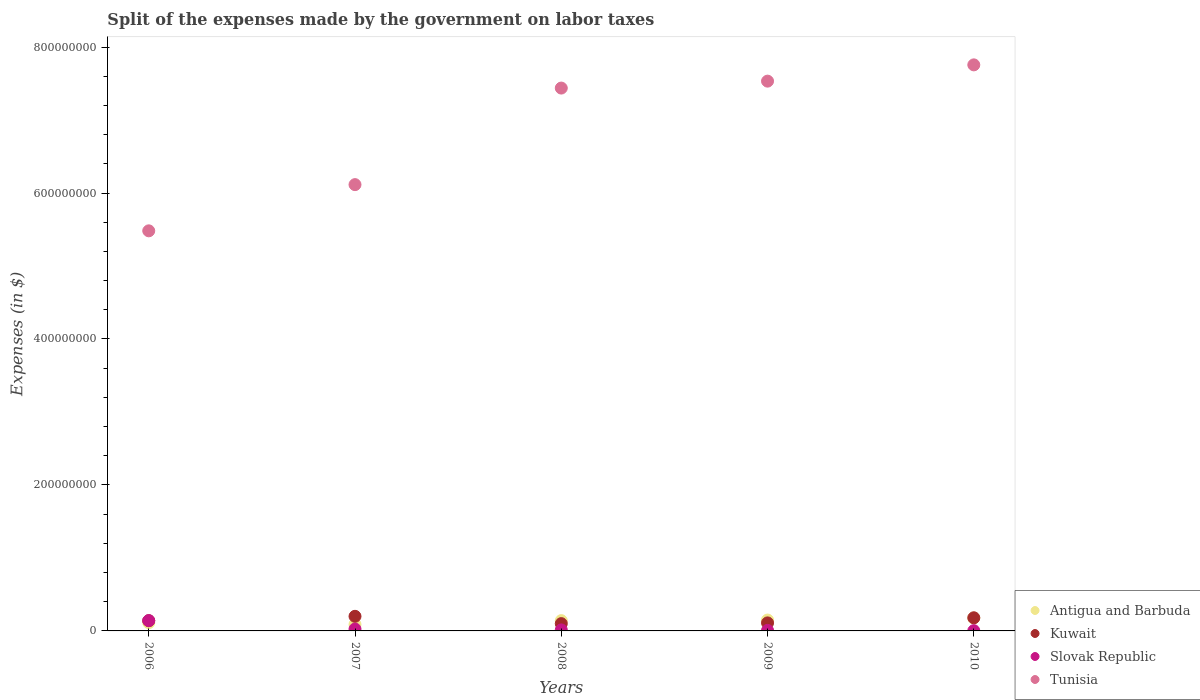What is the expenses made by the government on labor taxes in Tunisia in 2010?
Make the answer very short. 7.76e+08. Across all years, what is the maximum expenses made by the government on labor taxes in Tunisia?
Ensure brevity in your answer.  7.76e+08. Across all years, what is the minimum expenses made by the government on labor taxes in Antigua and Barbuda?
Offer a terse response. 8.90e+06. In which year was the expenses made by the government on labor taxes in Kuwait minimum?
Provide a short and direct response. 2008. What is the total expenses made by the government on labor taxes in Slovak Republic in the graph?
Your answer should be compact. 1.92e+07. What is the difference between the expenses made by the government on labor taxes in Antigua and Barbuda in 2008 and that in 2009?
Offer a terse response. -8.00e+05. What is the difference between the expenses made by the government on labor taxes in Tunisia in 2007 and the expenses made by the government on labor taxes in Antigua and Barbuda in 2009?
Offer a terse response. 5.97e+08. What is the average expenses made by the government on labor taxes in Antigua and Barbuda per year?
Keep it short and to the point. 1.34e+07. In the year 2009, what is the difference between the expenses made by the government on labor taxes in Slovak Republic and expenses made by the government on labor taxes in Tunisia?
Your response must be concise. -7.53e+08. What is the ratio of the expenses made by the government on labor taxes in Kuwait in 2007 to that in 2008?
Your answer should be very brief. 2. Is the difference between the expenses made by the government on labor taxes in Slovak Republic in 2007 and 2008 greater than the difference between the expenses made by the government on labor taxes in Tunisia in 2007 and 2008?
Make the answer very short. Yes. What is the difference between the highest and the second highest expenses made by the government on labor taxes in Tunisia?
Provide a short and direct response. 2.23e+07. What is the difference between the highest and the lowest expenses made by the government on labor taxes in Antigua and Barbuda?
Give a very brief answer. 8.80e+06. Is the sum of the expenses made by the government on labor taxes in Slovak Republic in 2009 and 2010 greater than the maximum expenses made by the government on labor taxes in Tunisia across all years?
Provide a succinct answer. No. Is it the case that in every year, the sum of the expenses made by the government on labor taxes in Tunisia and expenses made by the government on labor taxes in Antigua and Barbuda  is greater than the sum of expenses made by the government on labor taxes in Kuwait and expenses made by the government on labor taxes in Slovak Republic?
Your answer should be very brief. No. Does the expenses made by the government on labor taxes in Antigua and Barbuda monotonically increase over the years?
Make the answer very short. No. Is the expenses made by the government on labor taxes in Slovak Republic strictly greater than the expenses made by the government on labor taxes in Kuwait over the years?
Offer a terse response. No. Is the expenses made by the government on labor taxes in Antigua and Barbuda strictly less than the expenses made by the government on labor taxes in Tunisia over the years?
Your response must be concise. Yes. How many dotlines are there?
Your response must be concise. 4. What is the difference between two consecutive major ticks on the Y-axis?
Your answer should be very brief. 2.00e+08. Does the graph contain grids?
Offer a terse response. No. Where does the legend appear in the graph?
Keep it short and to the point. Bottom right. How many legend labels are there?
Give a very brief answer. 4. How are the legend labels stacked?
Your answer should be very brief. Vertical. What is the title of the graph?
Offer a very short reply. Split of the expenses made by the government on labor taxes. What is the label or title of the Y-axis?
Your answer should be very brief. Expenses (in $). What is the Expenses (in $) in Antigua and Barbuda in 2006?
Your answer should be very brief. 1.13e+07. What is the Expenses (in $) of Kuwait in 2006?
Ensure brevity in your answer.  1.40e+07. What is the Expenses (in $) in Slovak Republic in 2006?
Offer a terse response. 1.41e+07. What is the Expenses (in $) of Tunisia in 2006?
Keep it short and to the point. 5.48e+08. What is the Expenses (in $) of Antigua and Barbuda in 2007?
Your response must be concise. 8.90e+06. What is the Expenses (in $) in Slovak Republic in 2007?
Your answer should be compact. 2.58e+06. What is the Expenses (in $) of Tunisia in 2007?
Provide a short and direct response. 6.12e+08. What is the Expenses (in $) of Antigua and Barbuda in 2008?
Give a very brief answer. 1.41e+07. What is the Expenses (in $) in Slovak Republic in 2008?
Provide a short and direct response. 1.39e+06. What is the Expenses (in $) of Tunisia in 2008?
Offer a terse response. 7.44e+08. What is the Expenses (in $) of Antigua and Barbuda in 2009?
Provide a short and direct response. 1.49e+07. What is the Expenses (in $) of Kuwait in 2009?
Provide a succinct answer. 1.10e+07. What is the Expenses (in $) in Slovak Republic in 2009?
Give a very brief answer. 7.25e+05. What is the Expenses (in $) in Tunisia in 2009?
Give a very brief answer. 7.53e+08. What is the Expenses (in $) in Antigua and Barbuda in 2010?
Your response must be concise. 1.77e+07. What is the Expenses (in $) of Kuwait in 2010?
Provide a short and direct response. 1.80e+07. What is the Expenses (in $) of Slovak Republic in 2010?
Provide a succinct answer. 3.61e+05. What is the Expenses (in $) of Tunisia in 2010?
Make the answer very short. 7.76e+08. Across all years, what is the maximum Expenses (in $) of Antigua and Barbuda?
Provide a short and direct response. 1.77e+07. Across all years, what is the maximum Expenses (in $) in Kuwait?
Keep it short and to the point. 2.00e+07. Across all years, what is the maximum Expenses (in $) of Slovak Republic?
Your answer should be very brief. 1.41e+07. Across all years, what is the maximum Expenses (in $) of Tunisia?
Your response must be concise. 7.76e+08. Across all years, what is the minimum Expenses (in $) in Antigua and Barbuda?
Keep it short and to the point. 8.90e+06. Across all years, what is the minimum Expenses (in $) of Kuwait?
Keep it short and to the point. 1.00e+07. Across all years, what is the minimum Expenses (in $) of Slovak Republic?
Ensure brevity in your answer.  3.61e+05. Across all years, what is the minimum Expenses (in $) of Tunisia?
Provide a succinct answer. 5.48e+08. What is the total Expenses (in $) of Antigua and Barbuda in the graph?
Offer a very short reply. 6.69e+07. What is the total Expenses (in $) of Kuwait in the graph?
Make the answer very short. 7.30e+07. What is the total Expenses (in $) in Slovak Republic in the graph?
Ensure brevity in your answer.  1.92e+07. What is the total Expenses (in $) of Tunisia in the graph?
Make the answer very short. 3.43e+09. What is the difference between the Expenses (in $) of Antigua and Barbuda in 2006 and that in 2007?
Your answer should be very brief. 2.40e+06. What is the difference between the Expenses (in $) in Kuwait in 2006 and that in 2007?
Keep it short and to the point. -6.00e+06. What is the difference between the Expenses (in $) of Slovak Republic in 2006 and that in 2007?
Your answer should be compact. 1.15e+07. What is the difference between the Expenses (in $) of Tunisia in 2006 and that in 2007?
Keep it short and to the point. -6.33e+07. What is the difference between the Expenses (in $) of Antigua and Barbuda in 2006 and that in 2008?
Provide a short and direct response. -2.80e+06. What is the difference between the Expenses (in $) in Kuwait in 2006 and that in 2008?
Offer a very short reply. 4.00e+06. What is the difference between the Expenses (in $) in Slovak Republic in 2006 and that in 2008?
Ensure brevity in your answer.  1.27e+07. What is the difference between the Expenses (in $) in Tunisia in 2006 and that in 2008?
Offer a very short reply. -1.96e+08. What is the difference between the Expenses (in $) of Antigua and Barbuda in 2006 and that in 2009?
Your answer should be very brief. -3.60e+06. What is the difference between the Expenses (in $) in Slovak Republic in 2006 and that in 2009?
Keep it short and to the point. 1.34e+07. What is the difference between the Expenses (in $) in Tunisia in 2006 and that in 2009?
Keep it short and to the point. -2.05e+08. What is the difference between the Expenses (in $) in Antigua and Barbuda in 2006 and that in 2010?
Make the answer very short. -6.40e+06. What is the difference between the Expenses (in $) in Kuwait in 2006 and that in 2010?
Your response must be concise. -4.00e+06. What is the difference between the Expenses (in $) of Slovak Republic in 2006 and that in 2010?
Provide a short and direct response. 1.37e+07. What is the difference between the Expenses (in $) of Tunisia in 2006 and that in 2010?
Your answer should be very brief. -2.27e+08. What is the difference between the Expenses (in $) of Antigua and Barbuda in 2007 and that in 2008?
Give a very brief answer. -5.20e+06. What is the difference between the Expenses (in $) of Kuwait in 2007 and that in 2008?
Your answer should be compact. 1.00e+07. What is the difference between the Expenses (in $) in Slovak Republic in 2007 and that in 2008?
Your answer should be compact. 1.19e+06. What is the difference between the Expenses (in $) of Tunisia in 2007 and that in 2008?
Make the answer very short. -1.32e+08. What is the difference between the Expenses (in $) of Antigua and Barbuda in 2007 and that in 2009?
Ensure brevity in your answer.  -6.00e+06. What is the difference between the Expenses (in $) of Kuwait in 2007 and that in 2009?
Ensure brevity in your answer.  9.00e+06. What is the difference between the Expenses (in $) of Slovak Republic in 2007 and that in 2009?
Your answer should be compact. 1.86e+06. What is the difference between the Expenses (in $) in Tunisia in 2007 and that in 2009?
Your response must be concise. -1.42e+08. What is the difference between the Expenses (in $) of Antigua and Barbuda in 2007 and that in 2010?
Offer a very short reply. -8.80e+06. What is the difference between the Expenses (in $) in Slovak Republic in 2007 and that in 2010?
Keep it short and to the point. 2.22e+06. What is the difference between the Expenses (in $) of Tunisia in 2007 and that in 2010?
Ensure brevity in your answer.  -1.64e+08. What is the difference between the Expenses (in $) of Antigua and Barbuda in 2008 and that in 2009?
Keep it short and to the point. -8.00e+05. What is the difference between the Expenses (in $) of Kuwait in 2008 and that in 2009?
Your response must be concise. -1.00e+06. What is the difference between the Expenses (in $) in Slovak Republic in 2008 and that in 2009?
Make the answer very short. 6.67e+05. What is the difference between the Expenses (in $) of Tunisia in 2008 and that in 2009?
Provide a succinct answer. -9.50e+06. What is the difference between the Expenses (in $) of Antigua and Barbuda in 2008 and that in 2010?
Provide a succinct answer. -3.60e+06. What is the difference between the Expenses (in $) in Kuwait in 2008 and that in 2010?
Ensure brevity in your answer.  -8.00e+06. What is the difference between the Expenses (in $) of Slovak Republic in 2008 and that in 2010?
Your answer should be compact. 1.03e+06. What is the difference between the Expenses (in $) of Tunisia in 2008 and that in 2010?
Keep it short and to the point. -3.18e+07. What is the difference between the Expenses (in $) of Antigua and Barbuda in 2009 and that in 2010?
Your answer should be very brief. -2.80e+06. What is the difference between the Expenses (in $) of Kuwait in 2009 and that in 2010?
Ensure brevity in your answer.  -7.00e+06. What is the difference between the Expenses (in $) of Slovak Republic in 2009 and that in 2010?
Give a very brief answer. 3.64e+05. What is the difference between the Expenses (in $) of Tunisia in 2009 and that in 2010?
Make the answer very short. -2.23e+07. What is the difference between the Expenses (in $) in Antigua and Barbuda in 2006 and the Expenses (in $) in Kuwait in 2007?
Make the answer very short. -8.70e+06. What is the difference between the Expenses (in $) of Antigua and Barbuda in 2006 and the Expenses (in $) of Slovak Republic in 2007?
Offer a very short reply. 8.72e+06. What is the difference between the Expenses (in $) in Antigua and Barbuda in 2006 and the Expenses (in $) in Tunisia in 2007?
Provide a short and direct response. -6.00e+08. What is the difference between the Expenses (in $) of Kuwait in 2006 and the Expenses (in $) of Slovak Republic in 2007?
Give a very brief answer. 1.14e+07. What is the difference between the Expenses (in $) of Kuwait in 2006 and the Expenses (in $) of Tunisia in 2007?
Your response must be concise. -5.98e+08. What is the difference between the Expenses (in $) of Slovak Republic in 2006 and the Expenses (in $) of Tunisia in 2007?
Offer a very short reply. -5.97e+08. What is the difference between the Expenses (in $) of Antigua and Barbuda in 2006 and the Expenses (in $) of Kuwait in 2008?
Give a very brief answer. 1.30e+06. What is the difference between the Expenses (in $) in Antigua and Barbuda in 2006 and the Expenses (in $) in Slovak Republic in 2008?
Provide a short and direct response. 9.91e+06. What is the difference between the Expenses (in $) of Antigua and Barbuda in 2006 and the Expenses (in $) of Tunisia in 2008?
Make the answer very short. -7.32e+08. What is the difference between the Expenses (in $) in Kuwait in 2006 and the Expenses (in $) in Slovak Republic in 2008?
Your answer should be compact. 1.26e+07. What is the difference between the Expenses (in $) of Kuwait in 2006 and the Expenses (in $) of Tunisia in 2008?
Offer a very short reply. -7.30e+08. What is the difference between the Expenses (in $) in Slovak Republic in 2006 and the Expenses (in $) in Tunisia in 2008?
Your response must be concise. -7.30e+08. What is the difference between the Expenses (in $) of Antigua and Barbuda in 2006 and the Expenses (in $) of Slovak Republic in 2009?
Your answer should be compact. 1.06e+07. What is the difference between the Expenses (in $) in Antigua and Barbuda in 2006 and the Expenses (in $) in Tunisia in 2009?
Keep it short and to the point. -7.42e+08. What is the difference between the Expenses (in $) in Kuwait in 2006 and the Expenses (in $) in Slovak Republic in 2009?
Give a very brief answer. 1.33e+07. What is the difference between the Expenses (in $) of Kuwait in 2006 and the Expenses (in $) of Tunisia in 2009?
Provide a short and direct response. -7.39e+08. What is the difference between the Expenses (in $) in Slovak Republic in 2006 and the Expenses (in $) in Tunisia in 2009?
Make the answer very short. -7.39e+08. What is the difference between the Expenses (in $) of Antigua and Barbuda in 2006 and the Expenses (in $) of Kuwait in 2010?
Offer a terse response. -6.70e+06. What is the difference between the Expenses (in $) of Antigua and Barbuda in 2006 and the Expenses (in $) of Slovak Republic in 2010?
Keep it short and to the point. 1.09e+07. What is the difference between the Expenses (in $) of Antigua and Barbuda in 2006 and the Expenses (in $) of Tunisia in 2010?
Offer a very short reply. -7.64e+08. What is the difference between the Expenses (in $) in Kuwait in 2006 and the Expenses (in $) in Slovak Republic in 2010?
Offer a terse response. 1.36e+07. What is the difference between the Expenses (in $) of Kuwait in 2006 and the Expenses (in $) of Tunisia in 2010?
Offer a very short reply. -7.62e+08. What is the difference between the Expenses (in $) of Slovak Republic in 2006 and the Expenses (in $) of Tunisia in 2010?
Your answer should be compact. -7.61e+08. What is the difference between the Expenses (in $) in Antigua and Barbuda in 2007 and the Expenses (in $) in Kuwait in 2008?
Ensure brevity in your answer.  -1.10e+06. What is the difference between the Expenses (in $) in Antigua and Barbuda in 2007 and the Expenses (in $) in Slovak Republic in 2008?
Give a very brief answer. 7.51e+06. What is the difference between the Expenses (in $) of Antigua and Barbuda in 2007 and the Expenses (in $) of Tunisia in 2008?
Your answer should be compact. -7.35e+08. What is the difference between the Expenses (in $) in Kuwait in 2007 and the Expenses (in $) in Slovak Republic in 2008?
Provide a succinct answer. 1.86e+07. What is the difference between the Expenses (in $) in Kuwait in 2007 and the Expenses (in $) in Tunisia in 2008?
Offer a very short reply. -7.24e+08. What is the difference between the Expenses (in $) in Slovak Republic in 2007 and the Expenses (in $) in Tunisia in 2008?
Your response must be concise. -7.41e+08. What is the difference between the Expenses (in $) of Antigua and Barbuda in 2007 and the Expenses (in $) of Kuwait in 2009?
Provide a succinct answer. -2.10e+06. What is the difference between the Expenses (in $) of Antigua and Barbuda in 2007 and the Expenses (in $) of Slovak Republic in 2009?
Provide a succinct answer. 8.18e+06. What is the difference between the Expenses (in $) in Antigua and Barbuda in 2007 and the Expenses (in $) in Tunisia in 2009?
Provide a short and direct response. -7.44e+08. What is the difference between the Expenses (in $) of Kuwait in 2007 and the Expenses (in $) of Slovak Republic in 2009?
Your response must be concise. 1.93e+07. What is the difference between the Expenses (in $) in Kuwait in 2007 and the Expenses (in $) in Tunisia in 2009?
Provide a succinct answer. -7.33e+08. What is the difference between the Expenses (in $) in Slovak Republic in 2007 and the Expenses (in $) in Tunisia in 2009?
Give a very brief answer. -7.51e+08. What is the difference between the Expenses (in $) in Antigua and Barbuda in 2007 and the Expenses (in $) in Kuwait in 2010?
Ensure brevity in your answer.  -9.10e+06. What is the difference between the Expenses (in $) of Antigua and Barbuda in 2007 and the Expenses (in $) of Slovak Republic in 2010?
Provide a short and direct response. 8.54e+06. What is the difference between the Expenses (in $) in Antigua and Barbuda in 2007 and the Expenses (in $) in Tunisia in 2010?
Offer a terse response. -7.67e+08. What is the difference between the Expenses (in $) of Kuwait in 2007 and the Expenses (in $) of Slovak Republic in 2010?
Make the answer very short. 1.96e+07. What is the difference between the Expenses (in $) in Kuwait in 2007 and the Expenses (in $) in Tunisia in 2010?
Ensure brevity in your answer.  -7.56e+08. What is the difference between the Expenses (in $) of Slovak Republic in 2007 and the Expenses (in $) of Tunisia in 2010?
Offer a very short reply. -7.73e+08. What is the difference between the Expenses (in $) in Antigua and Barbuda in 2008 and the Expenses (in $) in Kuwait in 2009?
Keep it short and to the point. 3.10e+06. What is the difference between the Expenses (in $) of Antigua and Barbuda in 2008 and the Expenses (in $) of Slovak Republic in 2009?
Your answer should be compact. 1.34e+07. What is the difference between the Expenses (in $) of Antigua and Barbuda in 2008 and the Expenses (in $) of Tunisia in 2009?
Keep it short and to the point. -7.39e+08. What is the difference between the Expenses (in $) in Kuwait in 2008 and the Expenses (in $) in Slovak Republic in 2009?
Give a very brief answer. 9.28e+06. What is the difference between the Expenses (in $) in Kuwait in 2008 and the Expenses (in $) in Tunisia in 2009?
Provide a succinct answer. -7.43e+08. What is the difference between the Expenses (in $) in Slovak Republic in 2008 and the Expenses (in $) in Tunisia in 2009?
Your answer should be very brief. -7.52e+08. What is the difference between the Expenses (in $) of Antigua and Barbuda in 2008 and the Expenses (in $) of Kuwait in 2010?
Keep it short and to the point. -3.90e+06. What is the difference between the Expenses (in $) in Antigua and Barbuda in 2008 and the Expenses (in $) in Slovak Republic in 2010?
Provide a succinct answer. 1.37e+07. What is the difference between the Expenses (in $) of Antigua and Barbuda in 2008 and the Expenses (in $) of Tunisia in 2010?
Offer a very short reply. -7.62e+08. What is the difference between the Expenses (in $) of Kuwait in 2008 and the Expenses (in $) of Slovak Republic in 2010?
Your response must be concise. 9.64e+06. What is the difference between the Expenses (in $) in Kuwait in 2008 and the Expenses (in $) in Tunisia in 2010?
Provide a short and direct response. -7.66e+08. What is the difference between the Expenses (in $) of Slovak Republic in 2008 and the Expenses (in $) of Tunisia in 2010?
Your response must be concise. -7.74e+08. What is the difference between the Expenses (in $) of Antigua and Barbuda in 2009 and the Expenses (in $) of Kuwait in 2010?
Give a very brief answer. -3.10e+06. What is the difference between the Expenses (in $) in Antigua and Barbuda in 2009 and the Expenses (in $) in Slovak Republic in 2010?
Offer a terse response. 1.45e+07. What is the difference between the Expenses (in $) of Antigua and Barbuda in 2009 and the Expenses (in $) of Tunisia in 2010?
Provide a short and direct response. -7.61e+08. What is the difference between the Expenses (in $) of Kuwait in 2009 and the Expenses (in $) of Slovak Republic in 2010?
Your answer should be compact. 1.06e+07. What is the difference between the Expenses (in $) in Kuwait in 2009 and the Expenses (in $) in Tunisia in 2010?
Your answer should be very brief. -7.65e+08. What is the difference between the Expenses (in $) in Slovak Republic in 2009 and the Expenses (in $) in Tunisia in 2010?
Your answer should be very brief. -7.75e+08. What is the average Expenses (in $) of Antigua and Barbuda per year?
Provide a short and direct response. 1.34e+07. What is the average Expenses (in $) in Kuwait per year?
Provide a short and direct response. 1.46e+07. What is the average Expenses (in $) of Slovak Republic per year?
Give a very brief answer. 3.83e+06. What is the average Expenses (in $) of Tunisia per year?
Offer a very short reply. 6.86e+08. In the year 2006, what is the difference between the Expenses (in $) in Antigua and Barbuda and Expenses (in $) in Kuwait?
Give a very brief answer. -2.70e+06. In the year 2006, what is the difference between the Expenses (in $) of Antigua and Barbuda and Expenses (in $) of Slovak Republic?
Make the answer very short. -2.81e+06. In the year 2006, what is the difference between the Expenses (in $) in Antigua and Barbuda and Expenses (in $) in Tunisia?
Provide a succinct answer. -5.37e+08. In the year 2006, what is the difference between the Expenses (in $) in Kuwait and Expenses (in $) in Slovak Republic?
Offer a terse response. -1.07e+05. In the year 2006, what is the difference between the Expenses (in $) of Kuwait and Expenses (in $) of Tunisia?
Ensure brevity in your answer.  -5.34e+08. In the year 2006, what is the difference between the Expenses (in $) in Slovak Republic and Expenses (in $) in Tunisia?
Provide a succinct answer. -5.34e+08. In the year 2007, what is the difference between the Expenses (in $) in Antigua and Barbuda and Expenses (in $) in Kuwait?
Your response must be concise. -1.11e+07. In the year 2007, what is the difference between the Expenses (in $) of Antigua and Barbuda and Expenses (in $) of Slovak Republic?
Your answer should be very brief. 6.32e+06. In the year 2007, what is the difference between the Expenses (in $) in Antigua and Barbuda and Expenses (in $) in Tunisia?
Keep it short and to the point. -6.03e+08. In the year 2007, what is the difference between the Expenses (in $) in Kuwait and Expenses (in $) in Slovak Republic?
Keep it short and to the point. 1.74e+07. In the year 2007, what is the difference between the Expenses (in $) in Kuwait and Expenses (in $) in Tunisia?
Make the answer very short. -5.92e+08. In the year 2007, what is the difference between the Expenses (in $) of Slovak Republic and Expenses (in $) of Tunisia?
Your answer should be very brief. -6.09e+08. In the year 2008, what is the difference between the Expenses (in $) of Antigua and Barbuda and Expenses (in $) of Kuwait?
Ensure brevity in your answer.  4.10e+06. In the year 2008, what is the difference between the Expenses (in $) of Antigua and Barbuda and Expenses (in $) of Slovak Republic?
Give a very brief answer. 1.27e+07. In the year 2008, what is the difference between the Expenses (in $) in Antigua and Barbuda and Expenses (in $) in Tunisia?
Ensure brevity in your answer.  -7.30e+08. In the year 2008, what is the difference between the Expenses (in $) in Kuwait and Expenses (in $) in Slovak Republic?
Your answer should be compact. 8.61e+06. In the year 2008, what is the difference between the Expenses (in $) in Kuwait and Expenses (in $) in Tunisia?
Provide a succinct answer. -7.34e+08. In the year 2008, what is the difference between the Expenses (in $) of Slovak Republic and Expenses (in $) of Tunisia?
Make the answer very short. -7.42e+08. In the year 2009, what is the difference between the Expenses (in $) in Antigua and Barbuda and Expenses (in $) in Kuwait?
Your answer should be compact. 3.90e+06. In the year 2009, what is the difference between the Expenses (in $) of Antigua and Barbuda and Expenses (in $) of Slovak Republic?
Keep it short and to the point. 1.42e+07. In the year 2009, what is the difference between the Expenses (in $) of Antigua and Barbuda and Expenses (in $) of Tunisia?
Offer a terse response. -7.38e+08. In the year 2009, what is the difference between the Expenses (in $) in Kuwait and Expenses (in $) in Slovak Republic?
Your response must be concise. 1.03e+07. In the year 2009, what is the difference between the Expenses (in $) in Kuwait and Expenses (in $) in Tunisia?
Your response must be concise. -7.42e+08. In the year 2009, what is the difference between the Expenses (in $) of Slovak Republic and Expenses (in $) of Tunisia?
Provide a succinct answer. -7.53e+08. In the year 2010, what is the difference between the Expenses (in $) of Antigua and Barbuda and Expenses (in $) of Kuwait?
Your answer should be very brief. -3.00e+05. In the year 2010, what is the difference between the Expenses (in $) of Antigua and Barbuda and Expenses (in $) of Slovak Republic?
Your answer should be compact. 1.73e+07. In the year 2010, what is the difference between the Expenses (in $) of Antigua and Barbuda and Expenses (in $) of Tunisia?
Offer a terse response. -7.58e+08. In the year 2010, what is the difference between the Expenses (in $) of Kuwait and Expenses (in $) of Slovak Republic?
Give a very brief answer. 1.76e+07. In the year 2010, what is the difference between the Expenses (in $) in Kuwait and Expenses (in $) in Tunisia?
Your answer should be very brief. -7.58e+08. In the year 2010, what is the difference between the Expenses (in $) in Slovak Republic and Expenses (in $) in Tunisia?
Ensure brevity in your answer.  -7.75e+08. What is the ratio of the Expenses (in $) of Antigua and Barbuda in 2006 to that in 2007?
Provide a succinct answer. 1.27. What is the ratio of the Expenses (in $) of Kuwait in 2006 to that in 2007?
Make the answer very short. 0.7. What is the ratio of the Expenses (in $) in Slovak Republic in 2006 to that in 2007?
Make the answer very short. 5.46. What is the ratio of the Expenses (in $) of Tunisia in 2006 to that in 2007?
Your answer should be compact. 0.9. What is the ratio of the Expenses (in $) in Antigua and Barbuda in 2006 to that in 2008?
Make the answer very short. 0.8. What is the ratio of the Expenses (in $) in Kuwait in 2006 to that in 2008?
Your answer should be very brief. 1.4. What is the ratio of the Expenses (in $) in Slovak Republic in 2006 to that in 2008?
Keep it short and to the point. 10.14. What is the ratio of the Expenses (in $) of Tunisia in 2006 to that in 2008?
Your response must be concise. 0.74. What is the ratio of the Expenses (in $) in Antigua and Barbuda in 2006 to that in 2009?
Offer a terse response. 0.76. What is the ratio of the Expenses (in $) in Kuwait in 2006 to that in 2009?
Your answer should be compact. 1.27. What is the ratio of the Expenses (in $) in Slovak Republic in 2006 to that in 2009?
Keep it short and to the point. 19.46. What is the ratio of the Expenses (in $) in Tunisia in 2006 to that in 2009?
Offer a terse response. 0.73. What is the ratio of the Expenses (in $) in Antigua and Barbuda in 2006 to that in 2010?
Your response must be concise. 0.64. What is the ratio of the Expenses (in $) in Kuwait in 2006 to that in 2010?
Your answer should be compact. 0.78. What is the ratio of the Expenses (in $) of Slovak Republic in 2006 to that in 2010?
Keep it short and to the point. 39.06. What is the ratio of the Expenses (in $) of Tunisia in 2006 to that in 2010?
Your answer should be compact. 0.71. What is the ratio of the Expenses (in $) in Antigua and Barbuda in 2007 to that in 2008?
Your answer should be very brief. 0.63. What is the ratio of the Expenses (in $) in Kuwait in 2007 to that in 2008?
Your response must be concise. 2. What is the ratio of the Expenses (in $) of Slovak Republic in 2007 to that in 2008?
Give a very brief answer. 1.86. What is the ratio of the Expenses (in $) in Tunisia in 2007 to that in 2008?
Provide a short and direct response. 0.82. What is the ratio of the Expenses (in $) in Antigua and Barbuda in 2007 to that in 2009?
Your answer should be very brief. 0.6. What is the ratio of the Expenses (in $) of Kuwait in 2007 to that in 2009?
Ensure brevity in your answer.  1.82. What is the ratio of the Expenses (in $) of Slovak Republic in 2007 to that in 2009?
Provide a succinct answer. 3.56. What is the ratio of the Expenses (in $) in Tunisia in 2007 to that in 2009?
Offer a very short reply. 0.81. What is the ratio of the Expenses (in $) of Antigua and Barbuda in 2007 to that in 2010?
Your answer should be compact. 0.5. What is the ratio of the Expenses (in $) of Kuwait in 2007 to that in 2010?
Offer a very short reply. 1.11. What is the ratio of the Expenses (in $) in Slovak Republic in 2007 to that in 2010?
Give a very brief answer. 7.15. What is the ratio of the Expenses (in $) of Tunisia in 2007 to that in 2010?
Offer a terse response. 0.79. What is the ratio of the Expenses (in $) of Antigua and Barbuda in 2008 to that in 2009?
Offer a very short reply. 0.95. What is the ratio of the Expenses (in $) in Kuwait in 2008 to that in 2009?
Provide a succinct answer. 0.91. What is the ratio of the Expenses (in $) of Slovak Republic in 2008 to that in 2009?
Offer a very short reply. 1.92. What is the ratio of the Expenses (in $) in Tunisia in 2008 to that in 2009?
Offer a very short reply. 0.99. What is the ratio of the Expenses (in $) in Antigua and Barbuda in 2008 to that in 2010?
Ensure brevity in your answer.  0.8. What is the ratio of the Expenses (in $) in Kuwait in 2008 to that in 2010?
Make the answer very short. 0.56. What is the ratio of the Expenses (in $) of Slovak Republic in 2008 to that in 2010?
Make the answer very short. 3.85. What is the ratio of the Expenses (in $) of Tunisia in 2008 to that in 2010?
Offer a very short reply. 0.96. What is the ratio of the Expenses (in $) in Antigua and Barbuda in 2009 to that in 2010?
Ensure brevity in your answer.  0.84. What is the ratio of the Expenses (in $) in Kuwait in 2009 to that in 2010?
Make the answer very short. 0.61. What is the ratio of the Expenses (in $) of Slovak Republic in 2009 to that in 2010?
Ensure brevity in your answer.  2.01. What is the ratio of the Expenses (in $) of Tunisia in 2009 to that in 2010?
Offer a very short reply. 0.97. What is the difference between the highest and the second highest Expenses (in $) of Antigua and Barbuda?
Your answer should be very brief. 2.80e+06. What is the difference between the highest and the second highest Expenses (in $) of Kuwait?
Give a very brief answer. 2.00e+06. What is the difference between the highest and the second highest Expenses (in $) in Slovak Republic?
Keep it short and to the point. 1.15e+07. What is the difference between the highest and the second highest Expenses (in $) in Tunisia?
Provide a short and direct response. 2.23e+07. What is the difference between the highest and the lowest Expenses (in $) of Antigua and Barbuda?
Ensure brevity in your answer.  8.80e+06. What is the difference between the highest and the lowest Expenses (in $) of Kuwait?
Keep it short and to the point. 1.00e+07. What is the difference between the highest and the lowest Expenses (in $) in Slovak Republic?
Offer a very short reply. 1.37e+07. What is the difference between the highest and the lowest Expenses (in $) in Tunisia?
Make the answer very short. 2.27e+08. 